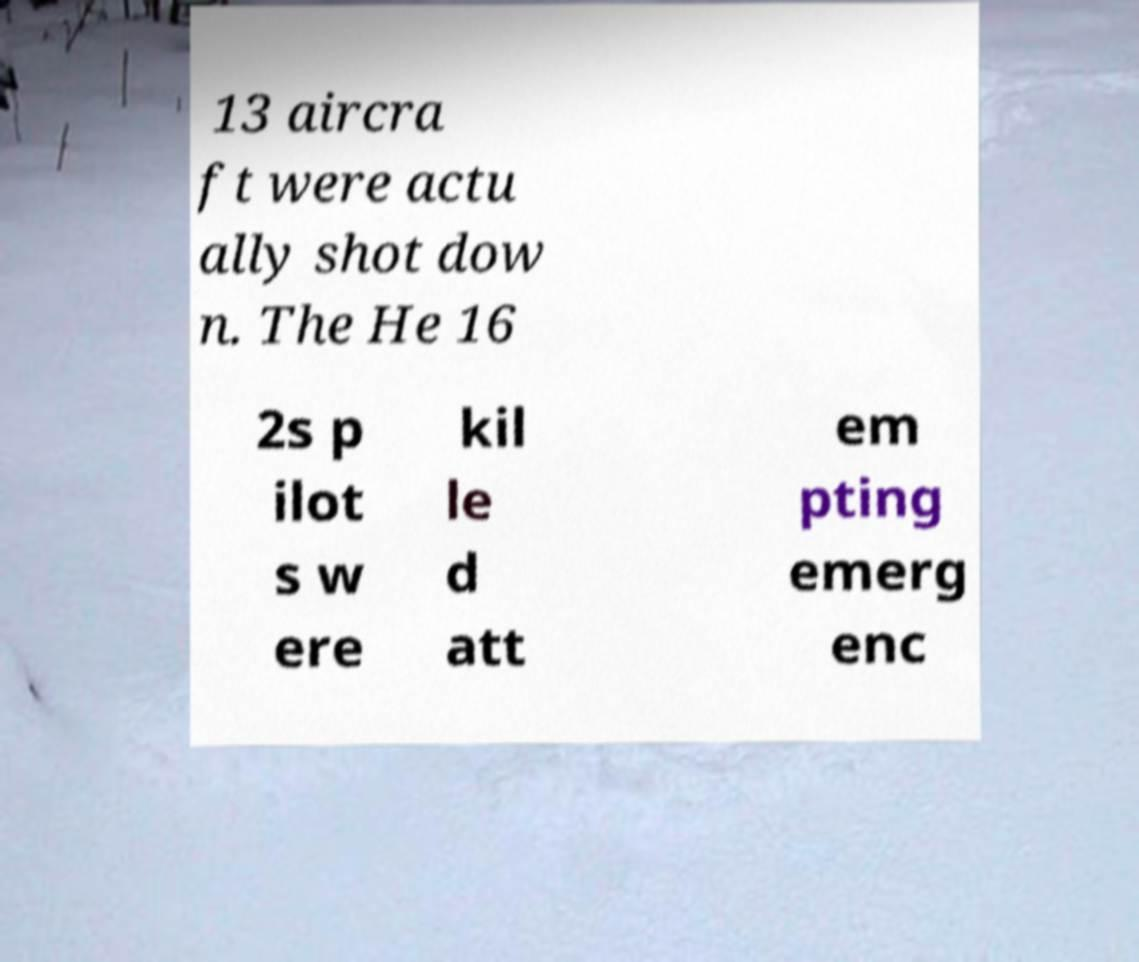Could you assist in decoding the text presented in this image and type it out clearly? 13 aircra ft were actu ally shot dow n. The He 16 2s p ilot s w ere kil le d att em pting emerg enc 